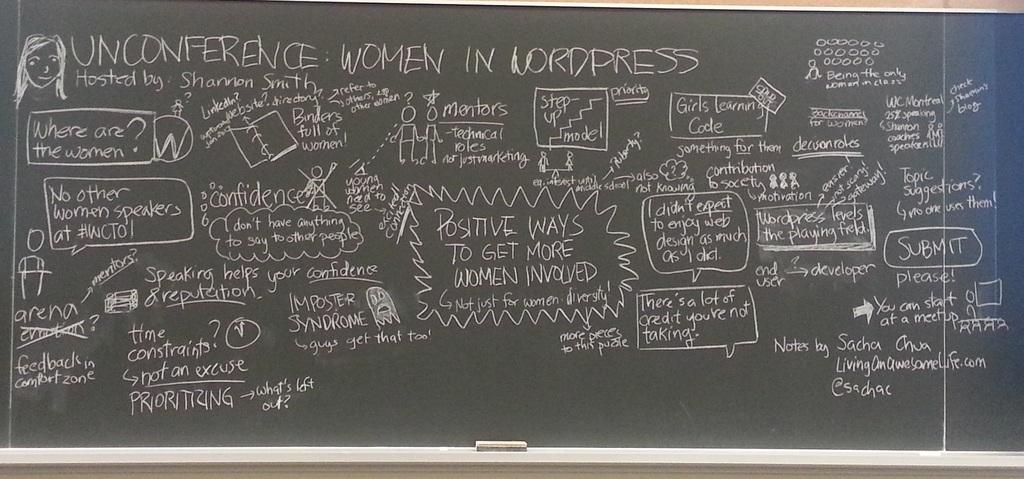<image>
Render a clear and concise summary of the photo. A chalkboard has information about Unconference: Women in Lordpress on it. 